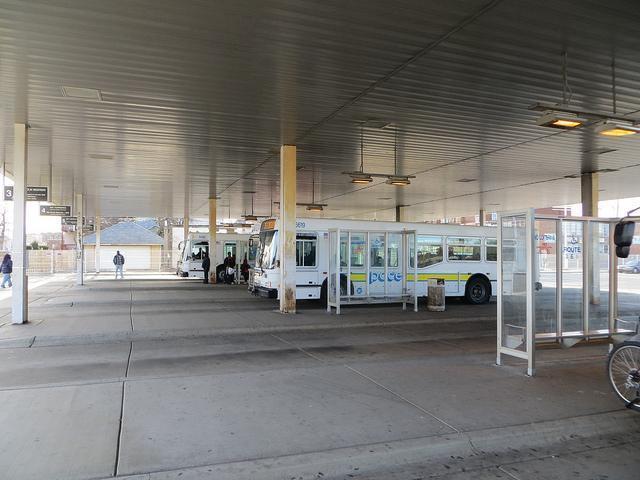How many buses are in the photo?
Give a very brief answer. 2. 